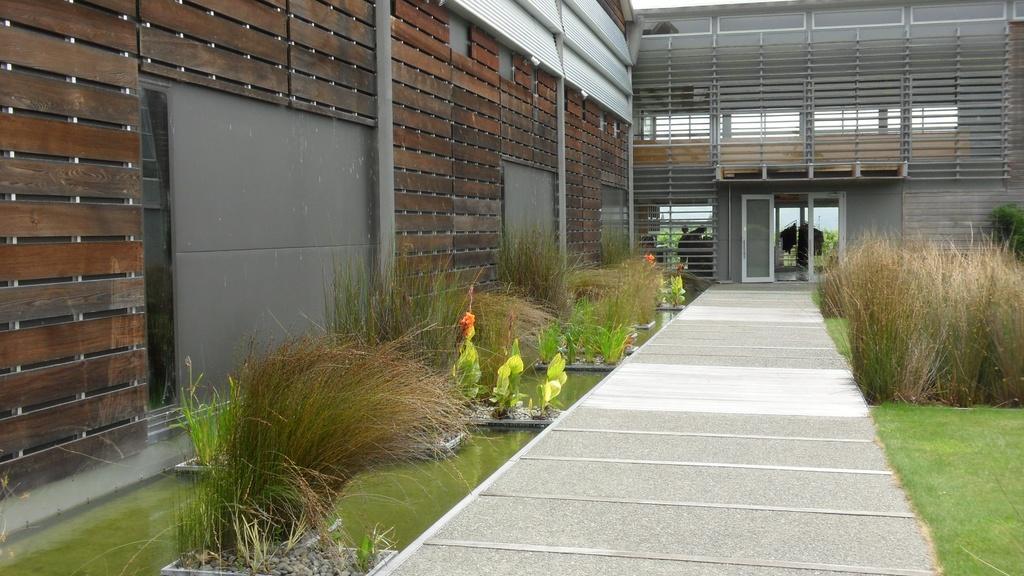How would you summarize this image in a sentence or two? Here we can see water, plants, and grass. There is a door and a building. 